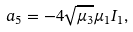<formula> <loc_0><loc_0><loc_500><loc_500>a _ { 5 } = - 4 \sqrt { \mu _ { 3 } } \mu _ { 1 } I _ { 1 } ,</formula> 